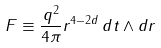Convert formula to latex. <formula><loc_0><loc_0><loc_500><loc_500>F \equiv \frac { q ^ { 2 } } { 4 \pi } r ^ { 4 - 2 d } \, d t \wedge d r</formula> 